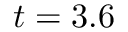<formula> <loc_0><loc_0><loc_500><loc_500>t = 3 . 6</formula> 